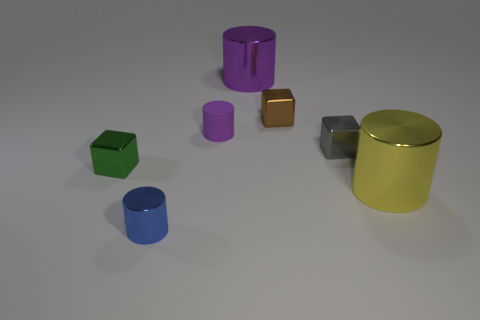Do the large metal object that is behind the yellow thing and the small matte cylinder have the same color?
Your answer should be compact. Yes. There is a block that is in front of the matte cylinder and to the right of the small green block; what color is it?
Ensure brevity in your answer.  Gray. There is a purple cylinder that is the same size as the yellow thing; what material is it?
Keep it short and to the point. Metal. What number of other things are made of the same material as the blue cylinder?
Your answer should be very brief. 5. Do the shiny cylinder that is behind the large yellow object and the small cylinder behind the blue object have the same color?
Keep it short and to the point. Yes. What shape is the tiny thing in front of the tiny thing left of the tiny metallic cylinder?
Your answer should be compact. Cylinder. How many other objects are there of the same color as the rubber cylinder?
Make the answer very short. 1. Do the big thing that is behind the small purple rubber thing and the small cube that is on the left side of the small purple object have the same material?
Your response must be concise. Yes. There is a metallic cylinder behind the small gray thing; what size is it?
Make the answer very short. Large. There is a tiny purple object that is the same shape as the large yellow metallic thing; what material is it?
Provide a short and direct response. Rubber. 